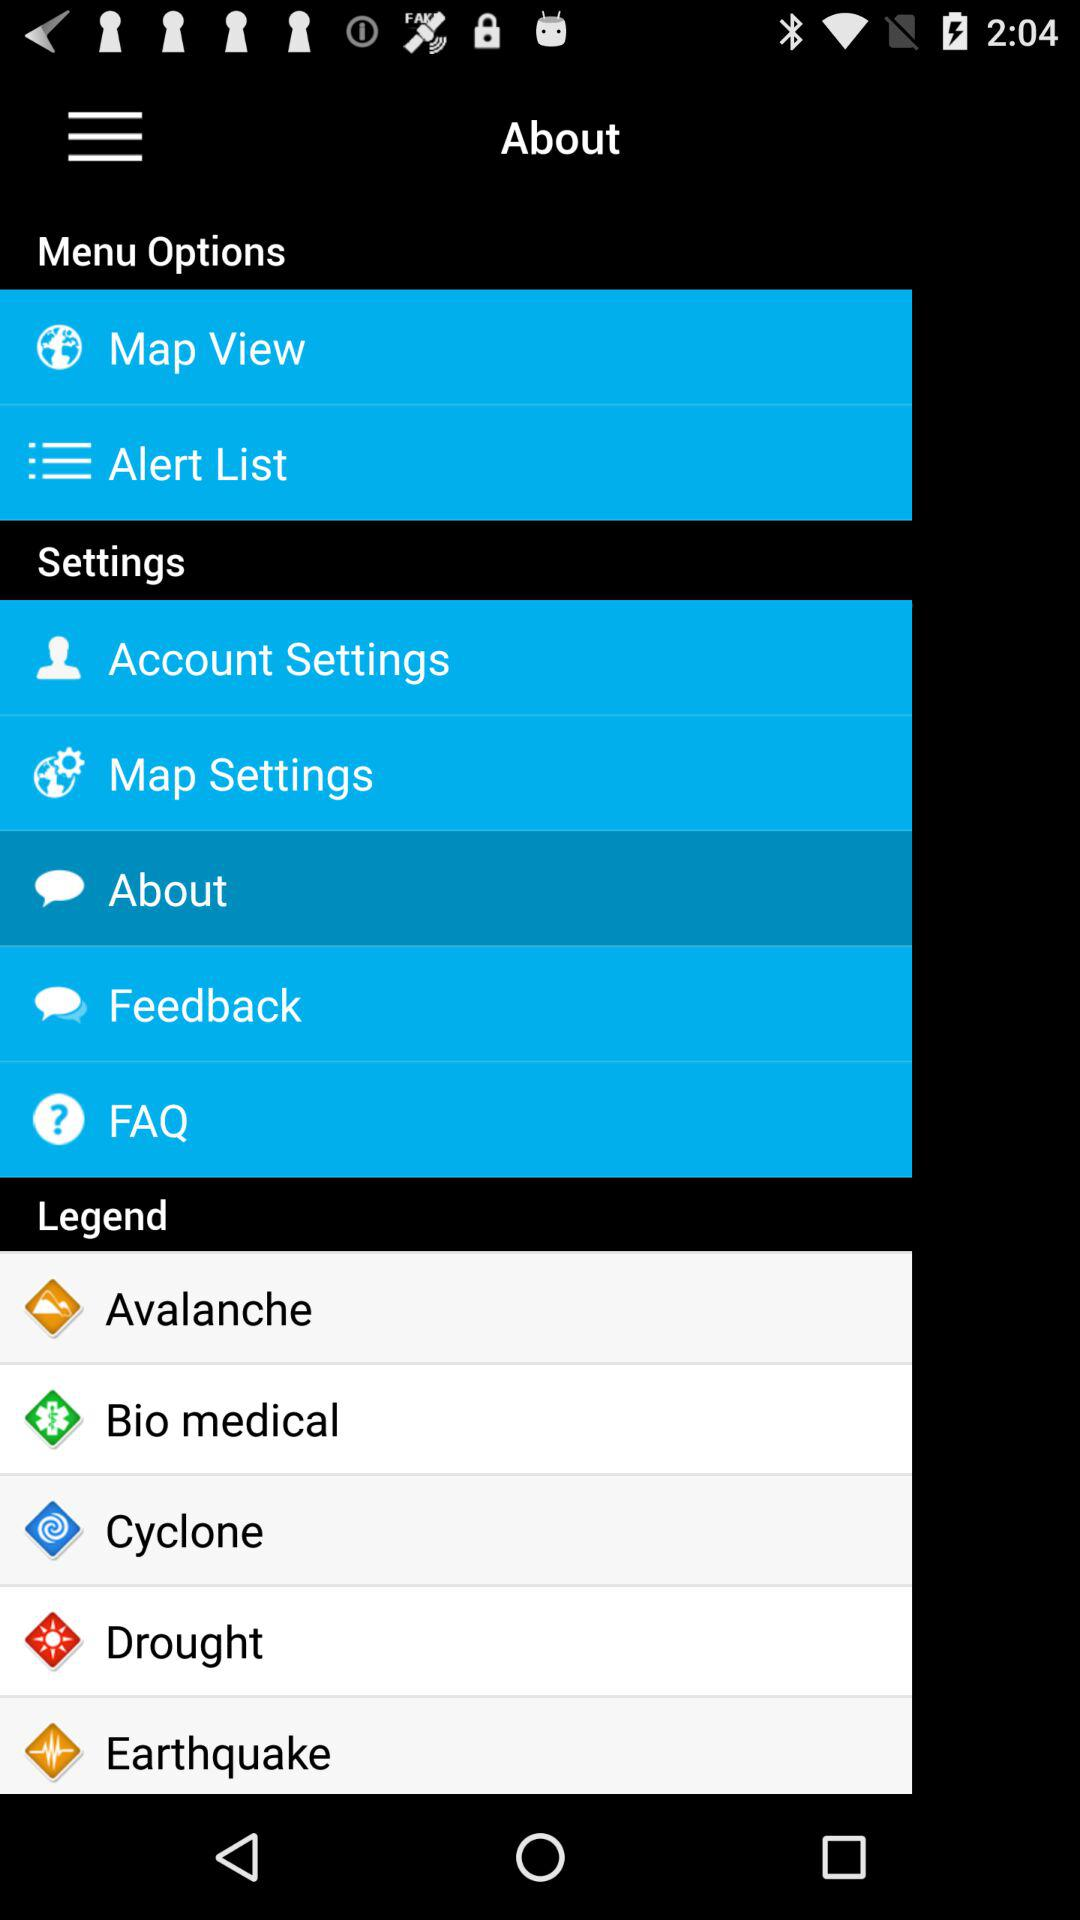Which item is selected in the menu? The selected item in the menu is "About". 